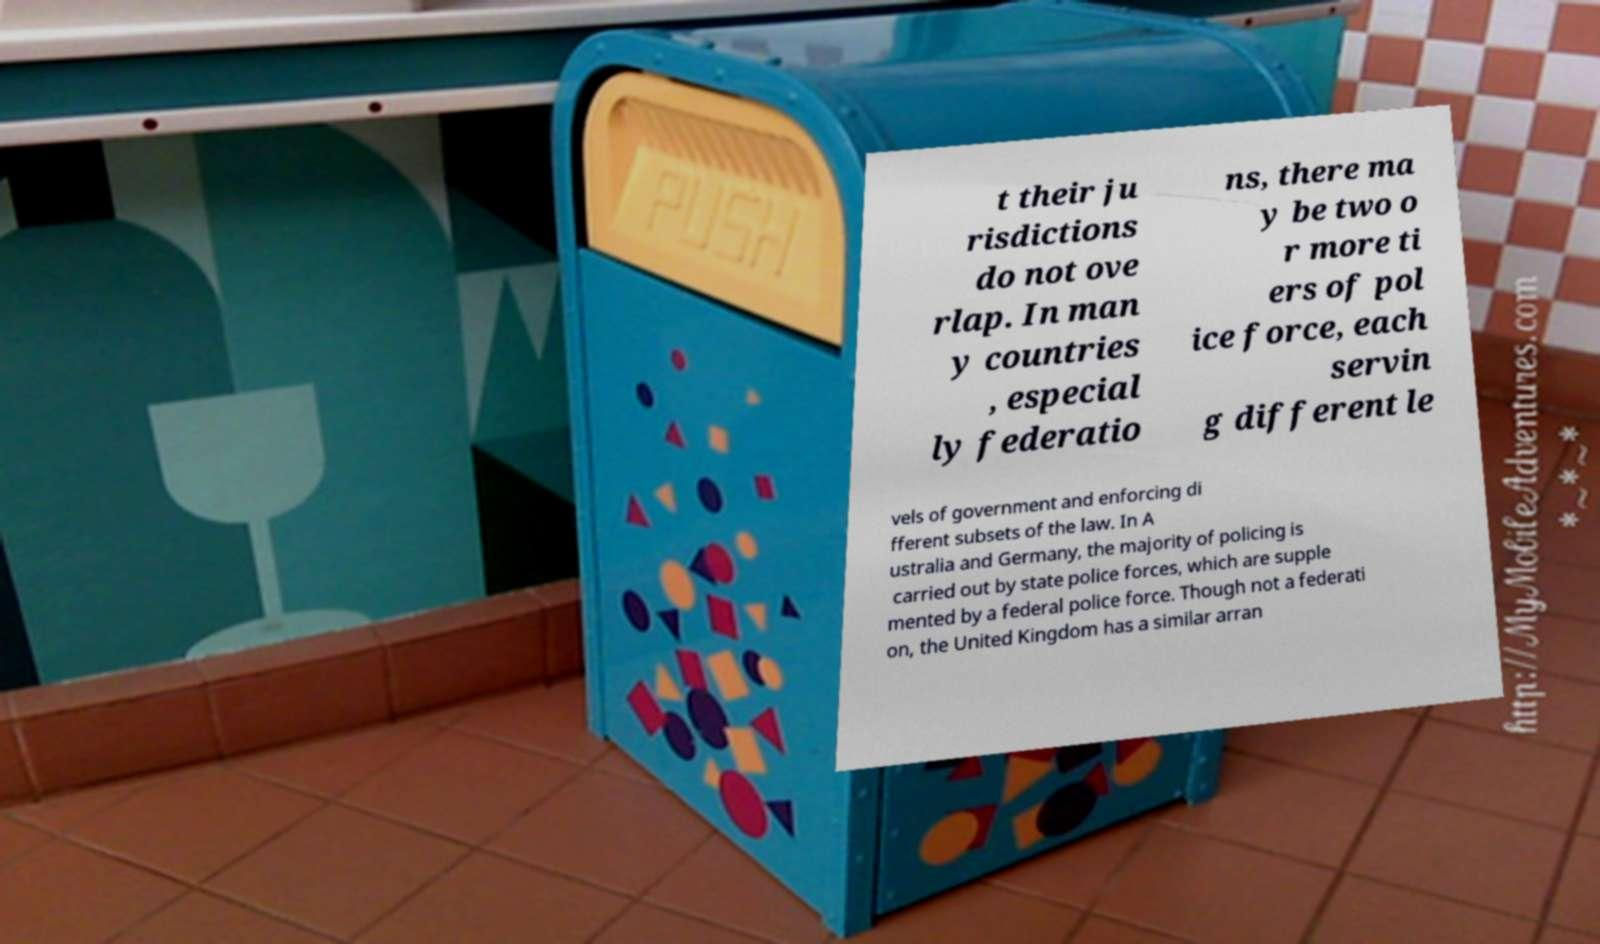What messages or text are displayed in this image? I need them in a readable, typed format. t their ju risdictions do not ove rlap. In man y countries , especial ly federatio ns, there ma y be two o r more ti ers of pol ice force, each servin g different le vels of government and enforcing di fferent subsets of the law. In A ustralia and Germany, the majority of policing is carried out by state police forces, which are supple mented by a federal police force. Though not a federati on, the United Kingdom has a similar arran 